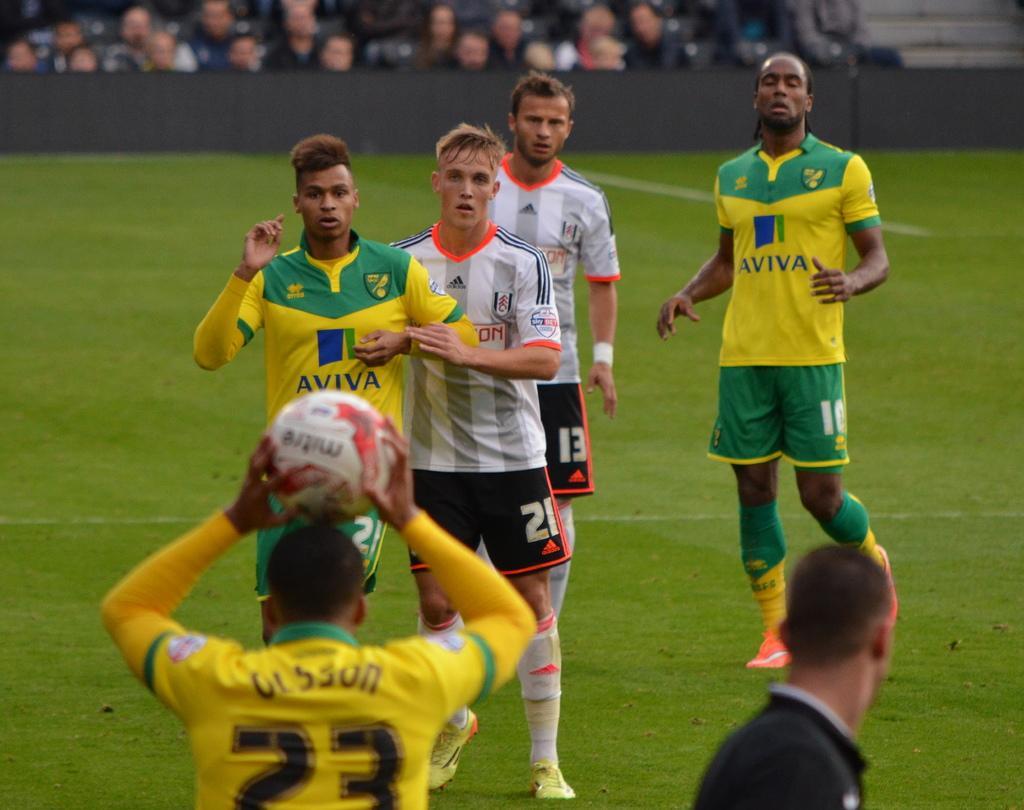Describe this image in one or two sentences. There are two teams playing with a ball in a ground. In the background we can observe some audience who are watching the match. 